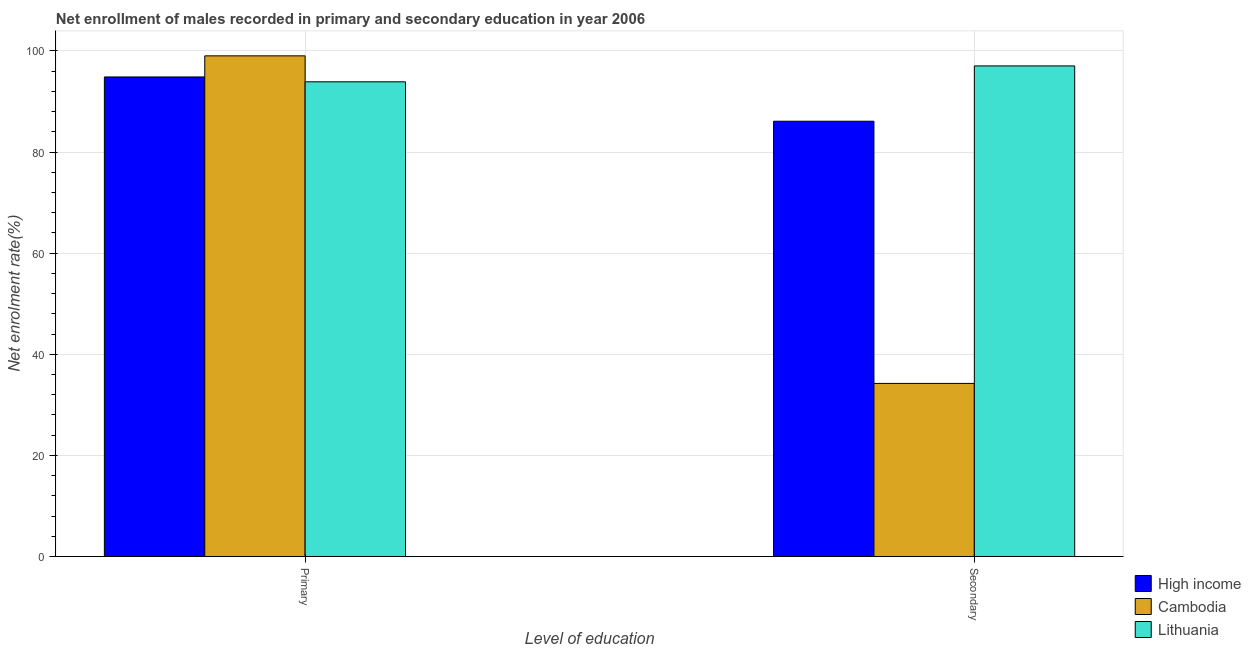How many different coloured bars are there?
Your response must be concise. 3. Are the number of bars per tick equal to the number of legend labels?
Give a very brief answer. Yes. How many bars are there on the 1st tick from the right?
Ensure brevity in your answer.  3. What is the label of the 1st group of bars from the left?
Offer a very short reply. Primary. What is the enrollment rate in secondary education in Cambodia?
Your answer should be compact. 34.24. Across all countries, what is the maximum enrollment rate in secondary education?
Your answer should be very brief. 97.03. Across all countries, what is the minimum enrollment rate in secondary education?
Your response must be concise. 34.24. In which country was the enrollment rate in primary education maximum?
Your answer should be very brief. Cambodia. In which country was the enrollment rate in secondary education minimum?
Your answer should be compact. Cambodia. What is the total enrollment rate in primary education in the graph?
Your answer should be compact. 287.76. What is the difference between the enrollment rate in secondary education in High income and that in Lithuania?
Make the answer very short. -10.94. What is the difference between the enrollment rate in secondary education in Lithuania and the enrollment rate in primary education in High income?
Your response must be concise. 2.18. What is the average enrollment rate in secondary education per country?
Provide a short and direct response. 72.45. What is the difference between the enrollment rate in secondary education and enrollment rate in primary education in Lithuania?
Your answer should be compact. 3.14. What is the ratio of the enrollment rate in primary education in High income to that in Cambodia?
Give a very brief answer. 0.96. In how many countries, is the enrollment rate in primary education greater than the average enrollment rate in primary education taken over all countries?
Your answer should be compact. 1. What does the 3rd bar from the left in Primary represents?
Offer a very short reply. Lithuania. What does the 2nd bar from the right in Primary represents?
Keep it short and to the point. Cambodia. How many bars are there?
Offer a very short reply. 6. Are all the bars in the graph horizontal?
Ensure brevity in your answer.  No. How many countries are there in the graph?
Your response must be concise. 3. Are the values on the major ticks of Y-axis written in scientific E-notation?
Your answer should be compact. No. How many legend labels are there?
Your answer should be very brief. 3. How are the legend labels stacked?
Provide a succinct answer. Vertical. What is the title of the graph?
Provide a short and direct response. Net enrollment of males recorded in primary and secondary education in year 2006. Does "Grenada" appear as one of the legend labels in the graph?
Provide a short and direct response. No. What is the label or title of the X-axis?
Make the answer very short. Level of education. What is the label or title of the Y-axis?
Provide a short and direct response. Net enrolment rate(%). What is the Net enrolment rate(%) in High income in Primary?
Your answer should be very brief. 94.85. What is the Net enrolment rate(%) in Cambodia in Primary?
Offer a very short reply. 99.02. What is the Net enrolment rate(%) in Lithuania in Primary?
Your response must be concise. 93.89. What is the Net enrolment rate(%) in High income in Secondary?
Your answer should be very brief. 86.09. What is the Net enrolment rate(%) of Cambodia in Secondary?
Ensure brevity in your answer.  34.24. What is the Net enrolment rate(%) of Lithuania in Secondary?
Give a very brief answer. 97.03. Across all Level of education, what is the maximum Net enrolment rate(%) in High income?
Your answer should be compact. 94.85. Across all Level of education, what is the maximum Net enrolment rate(%) in Cambodia?
Ensure brevity in your answer.  99.02. Across all Level of education, what is the maximum Net enrolment rate(%) of Lithuania?
Your answer should be compact. 97.03. Across all Level of education, what is the minimum Net enrolment rate(%) in High income?
Your response must be concise. 86.09. Across all Level of education, what is the minimum Net enrolment rate(%) in Cambodia?
Your answer should be very brief. 34.24. Across all Level of education, what is the minimum Net enrolment rate(%) of Lithuania?
Your answer should be very brief. 93.89. What is the total Net enrolment rate(%) in High income in the graph?
Your answer should be very brief. 180.94. What is the total Net enrolment rate(%) in Cambodia in the graph?
Provide a succinct answer. 133.26. What is the total Net enrolment rate(%) of Lithuania in the graph?
Provide a succinct answer. 190.92. What is the difference between the Net enrolment rate(%) in High income in Primary and that in Secondary?
Provide a short and direct response. 8.76. What is the difference between the Net enrolment rate(%) of Cambodia in Primary and that in Secondary?
Your response must be concise. 64.78. What is the difference between the Net enrolment rate(%) in Lithuania in Primary and that in Secondary?
Your response must be concise. -3.14. What is the difference between the Net enrolment rate(%) in High income in Primary and the Net enrolment rate(%) in Cambodia in Secondary?
Give a very brief answer. 60.61. What is the difference between the Net enrolment rate(%) of High income in Primary and the Net enrolment rate(%) of Lithuania in Secondary?
Ensure brevity in your answer.  -2.18. What is the difference between the Net enrolment rate(%) in Cambodia in Primary and the Net enrolment rate(%) in Lithuania in Secondary?
Provide a succinct answer. 1.99. What is the average Net enrolment rate(%) of High income per Level of education?
Your response must be concise. 90.47. What is the average Net enrolment rate(%) in Cambodia per Level of education?
Provide a short and direct response. 66.63. What is the average Net enrolment rate(%) in Lithuania per Level of education?
Ensure brevity in your answer.  95.46. What is the difference between the Net enrolment rate(%) in High income and Net enrolment rate(%) in Cambodia in Primary?
Provide a short and direct response. -4.17. What is the difference between the Net enrolment rate(%) of High income and Net enrolment rate(%) of Lithuania in Primary?
Offer a terse response. 0.96. What is the difference between the Net enrolment rate(%) of Cambodia and Net enrolment rate(%) of Lithuania in Primary?
Make the answer very short. 5.13. What is the difference between the Net enrolment rate(%) in High income and Net enrolment rate(%) in Cambodia in Secondary?
Your answer should be compact. 51.85. What is the difference between the Net enrolment rate(%) of High income and Net enrolment rate(%) of Lithuania in Secondary?
Your answer should be very brief. -10.94. What is the difference between the Net enrolment rate(%) in Cambodia and Net enrolment rate(%) in Lithuania in Secondary?
Keep it short and to the point. -62.79. What is the ratio of the Net enrolment rate(%) of High income in Primary to that in Secondary?
Your response must be concise. 1.1. What is the ratio of the Net enrolment rate(%) in Cambodia in Primary to that in Secondary?
Give a very brief answer. 2.89. What is the ratio of the Net enrolment rate(%) of Lithuania in Primary to that in Secondary?
Offer a terse response. 0.97. What is the difference between the highest and the second highest Net enrolment rate(%) in High income?
Ensure brevity in your answer.  8.76. What is the difference between the highest and the second highest Net enrolment rate(%) in Cambodia?
Ensure brevity in your answer.  64.78. What is the difference between the highest and the second highest Net enrolment rate(%) in Lithuania?
Make the answer very short. 3.14. What is the difference between the highest and the lowest Net enrolment rate(%) of High income?
Keep it short and to the point. 8.76. What is the difference between the highest and the lowest Net enrolment rate(%) in Cambodia?
Ensure brevity in your answer.  64.78. What is the difference between the highest and the lowest Net enrolment rate(%) of Lithuania?
Offer a very short reply. 3.14. 